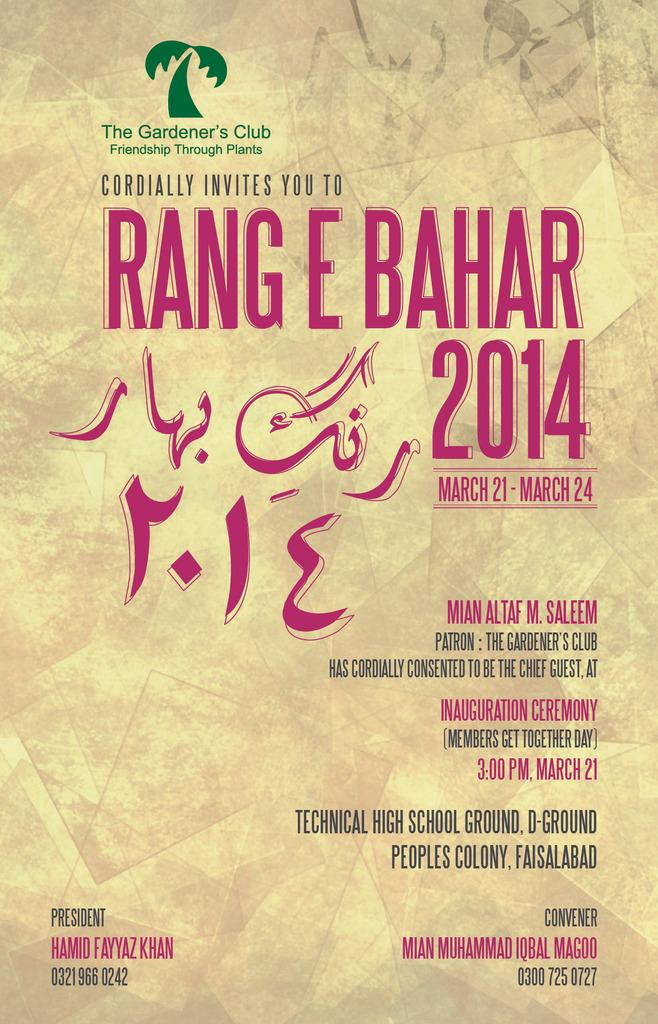What is present in the image that contains information or a message? There is a poster in the image. What can be found on the poster besides the image? There is text on the poster. What type of dog can be seen interacting with the hammer in the image? There is no dog or hammer present in the image; it only features a poster with text. Are there any dinosaurs visible in the image? There are no dinosaurs present in the image; it only features a poster with text. 